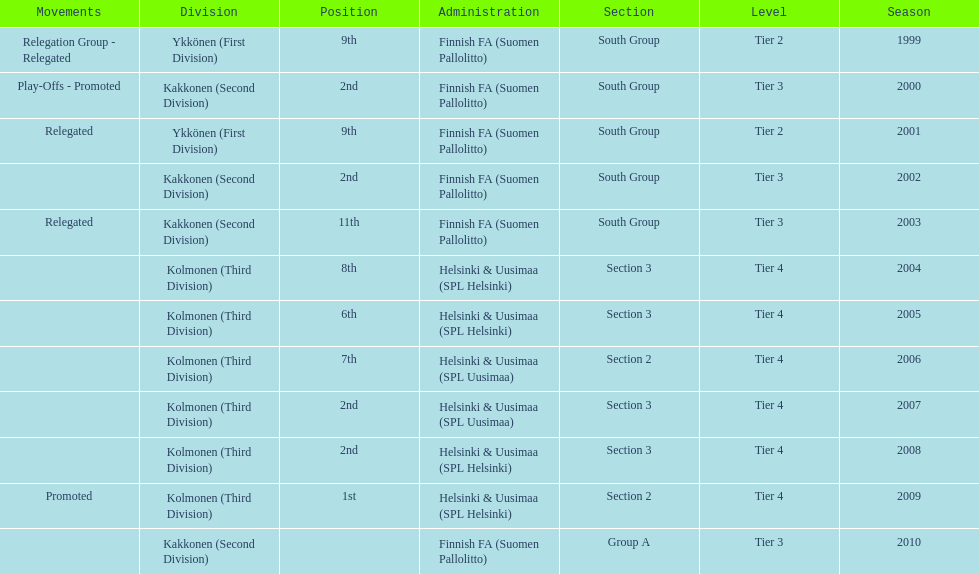Can you parse all the data within this table? {'header': ['Movements', 'Division', 'Position', 'Administration', 'Section', 'Level', 'Season'], 'rows': [['Relegation Group - Relegated', 'Ykkönen (First Division)', '9th', 'Finnish FA (Suomen Pallolitto)', 'South Group', 'Tier 2', '1999'], ['Play-Offs - Promoted', 'Kakkonen (Second Division)', '2nd', 'Finnish FA (Suomen Pallolitto)', 'South Group', 'Tier 3', '2000'], ['Relegated', 'Ykkönen (First Division)', '9th', 'Finnish FA (Suomen Pallolitto)', 'South Group', 'Tier 2', '2001'], ['', 'Kakkonen (Second Division)', '2nd', 'Finnish FA (Suomen Pallolitto)', 'South Group', 'Tier 3', '2002'], ['Relegated', 'Kakkonen (Second Division)', '11th', 'Finnish FA (Suomen Pallolitto)', 'South Group', 'Tier 3', '2003'], ['', 'Kolmonen (Third Division)', '8th', 'Helsinki & Uusimaa (SPL Helsinki)', 'Section 3', 'Tier 4', '2004'], ['', 'Kolmonen (Third Division)', '6th', 'Helsinki & Uusimaa (SPL Helsinki)', 'Section 3', 'Tier 4', '2005'], ['', 'Kolmonen (Third Division)', '7th', 'Helsinki & Uusimaa (SPL Uusimaa)', 'Section 2', 'Tier 4', '2006'], ['', 'Kolmonen (Third Division)', '2nd', 'Helsinki & Uusimaa (SPL Uusimaa)', 'Section 3', 'Tier 4', '2007'], ['', 'Kolmonen (Third Division)', '2nd', 'Helsinki & Uusimaa (SPL Helsinki)', 'Section 3', 'Tier 4', '2008'], ['Promoted', 'Kolmonen (Third Division)', '1st', 'Helsinki & Uusimaa (SPL Helsinki)', 'Section 2', 'Tier 4', '2009'], ['', 'Kakkonen (Second Division)', '', 'Finnish FA (Suomen Pallolitto)', 'Group A', 'Tier 3', '2010']]} What division were they in the most, section 3 or 2? 3. 